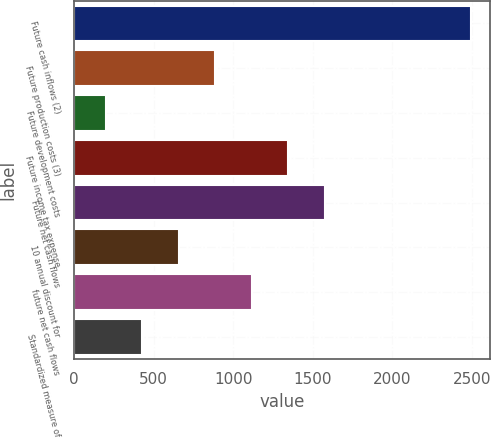Convert chart to OTSL. <chart><loc_0><loc_0><loc_500><loc_500><bar_chart><fcel>Future cash inflows (2)<fcel>Future production costs (3)<fcel>Future development costs<fcel>Future income tax expense<fcel>Future net cash flows<fcel>10 annual discount for<fcel>future net cash flows<fcel>Standardized measure of<nl><fcel>2492<fcel>887.6<fcel>200<fcel>1346<fcel>1575.2<fcel>658.4<fcel>1116.8<fcel>429.2<nl></chart> 